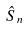<formula> <loc_0><loc_0><loc_500><loc_500>\hat { S } _ { n }</formula> 